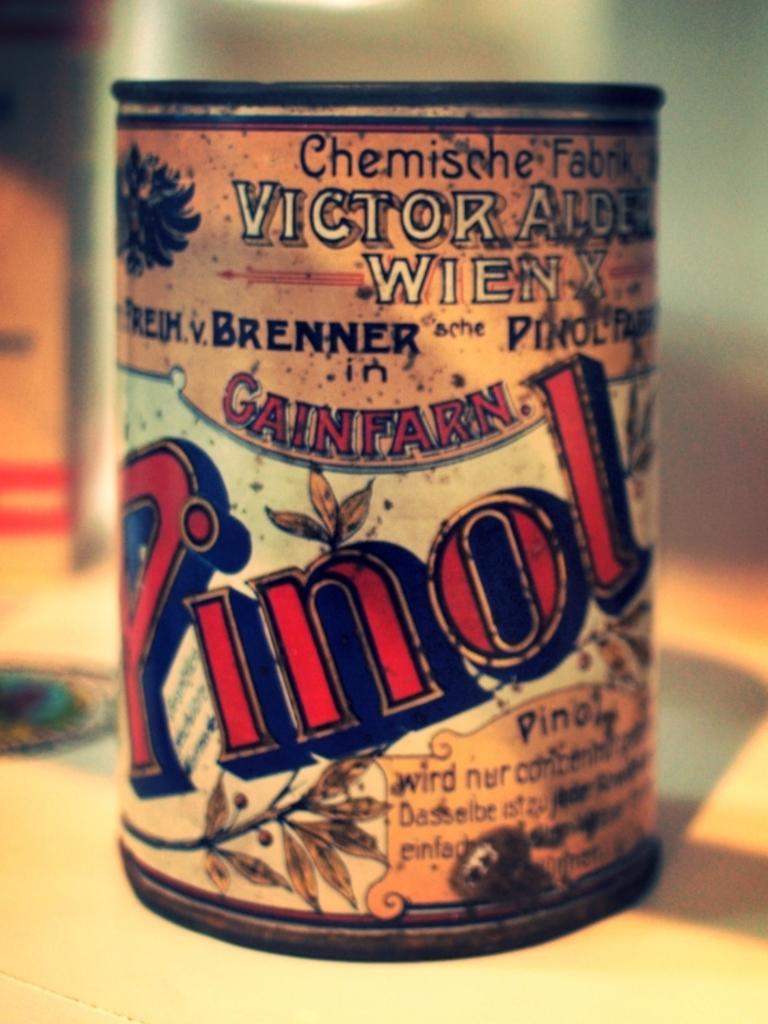What word is the largest on this can?
Offer a very short reply. Pinol. 